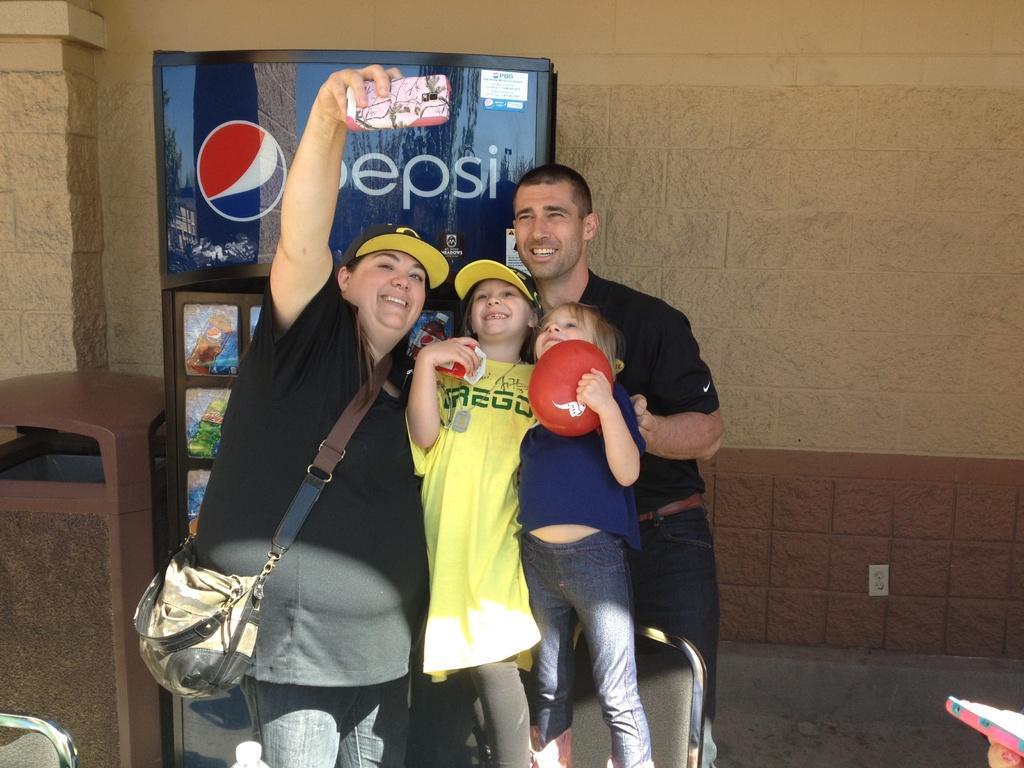Could you give a brief overview of what you see in this image? In this picture there is a lady and a man with two children in the center of the image, she is taking a snap, there is a refrigerator on the left side of the image, behind the lady. 